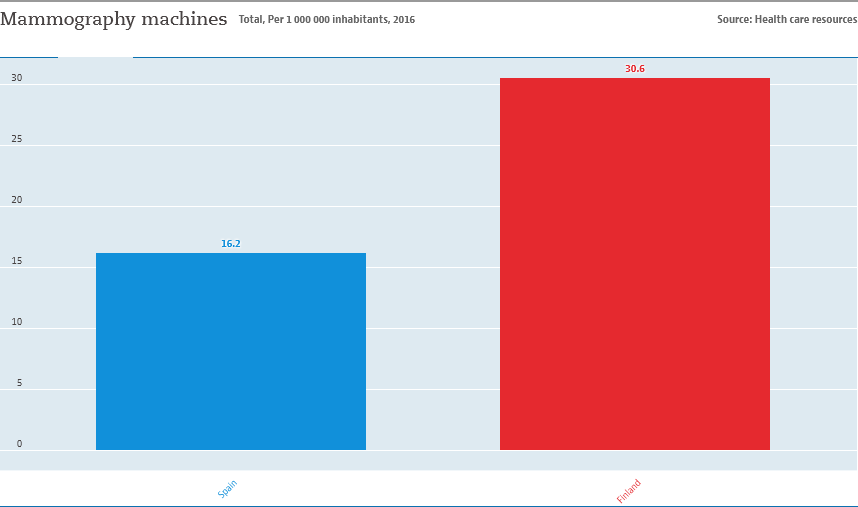List a handful of essential elements in this visual. The average value of both bars is 23.4. The country represented by the red bar is Finland. 